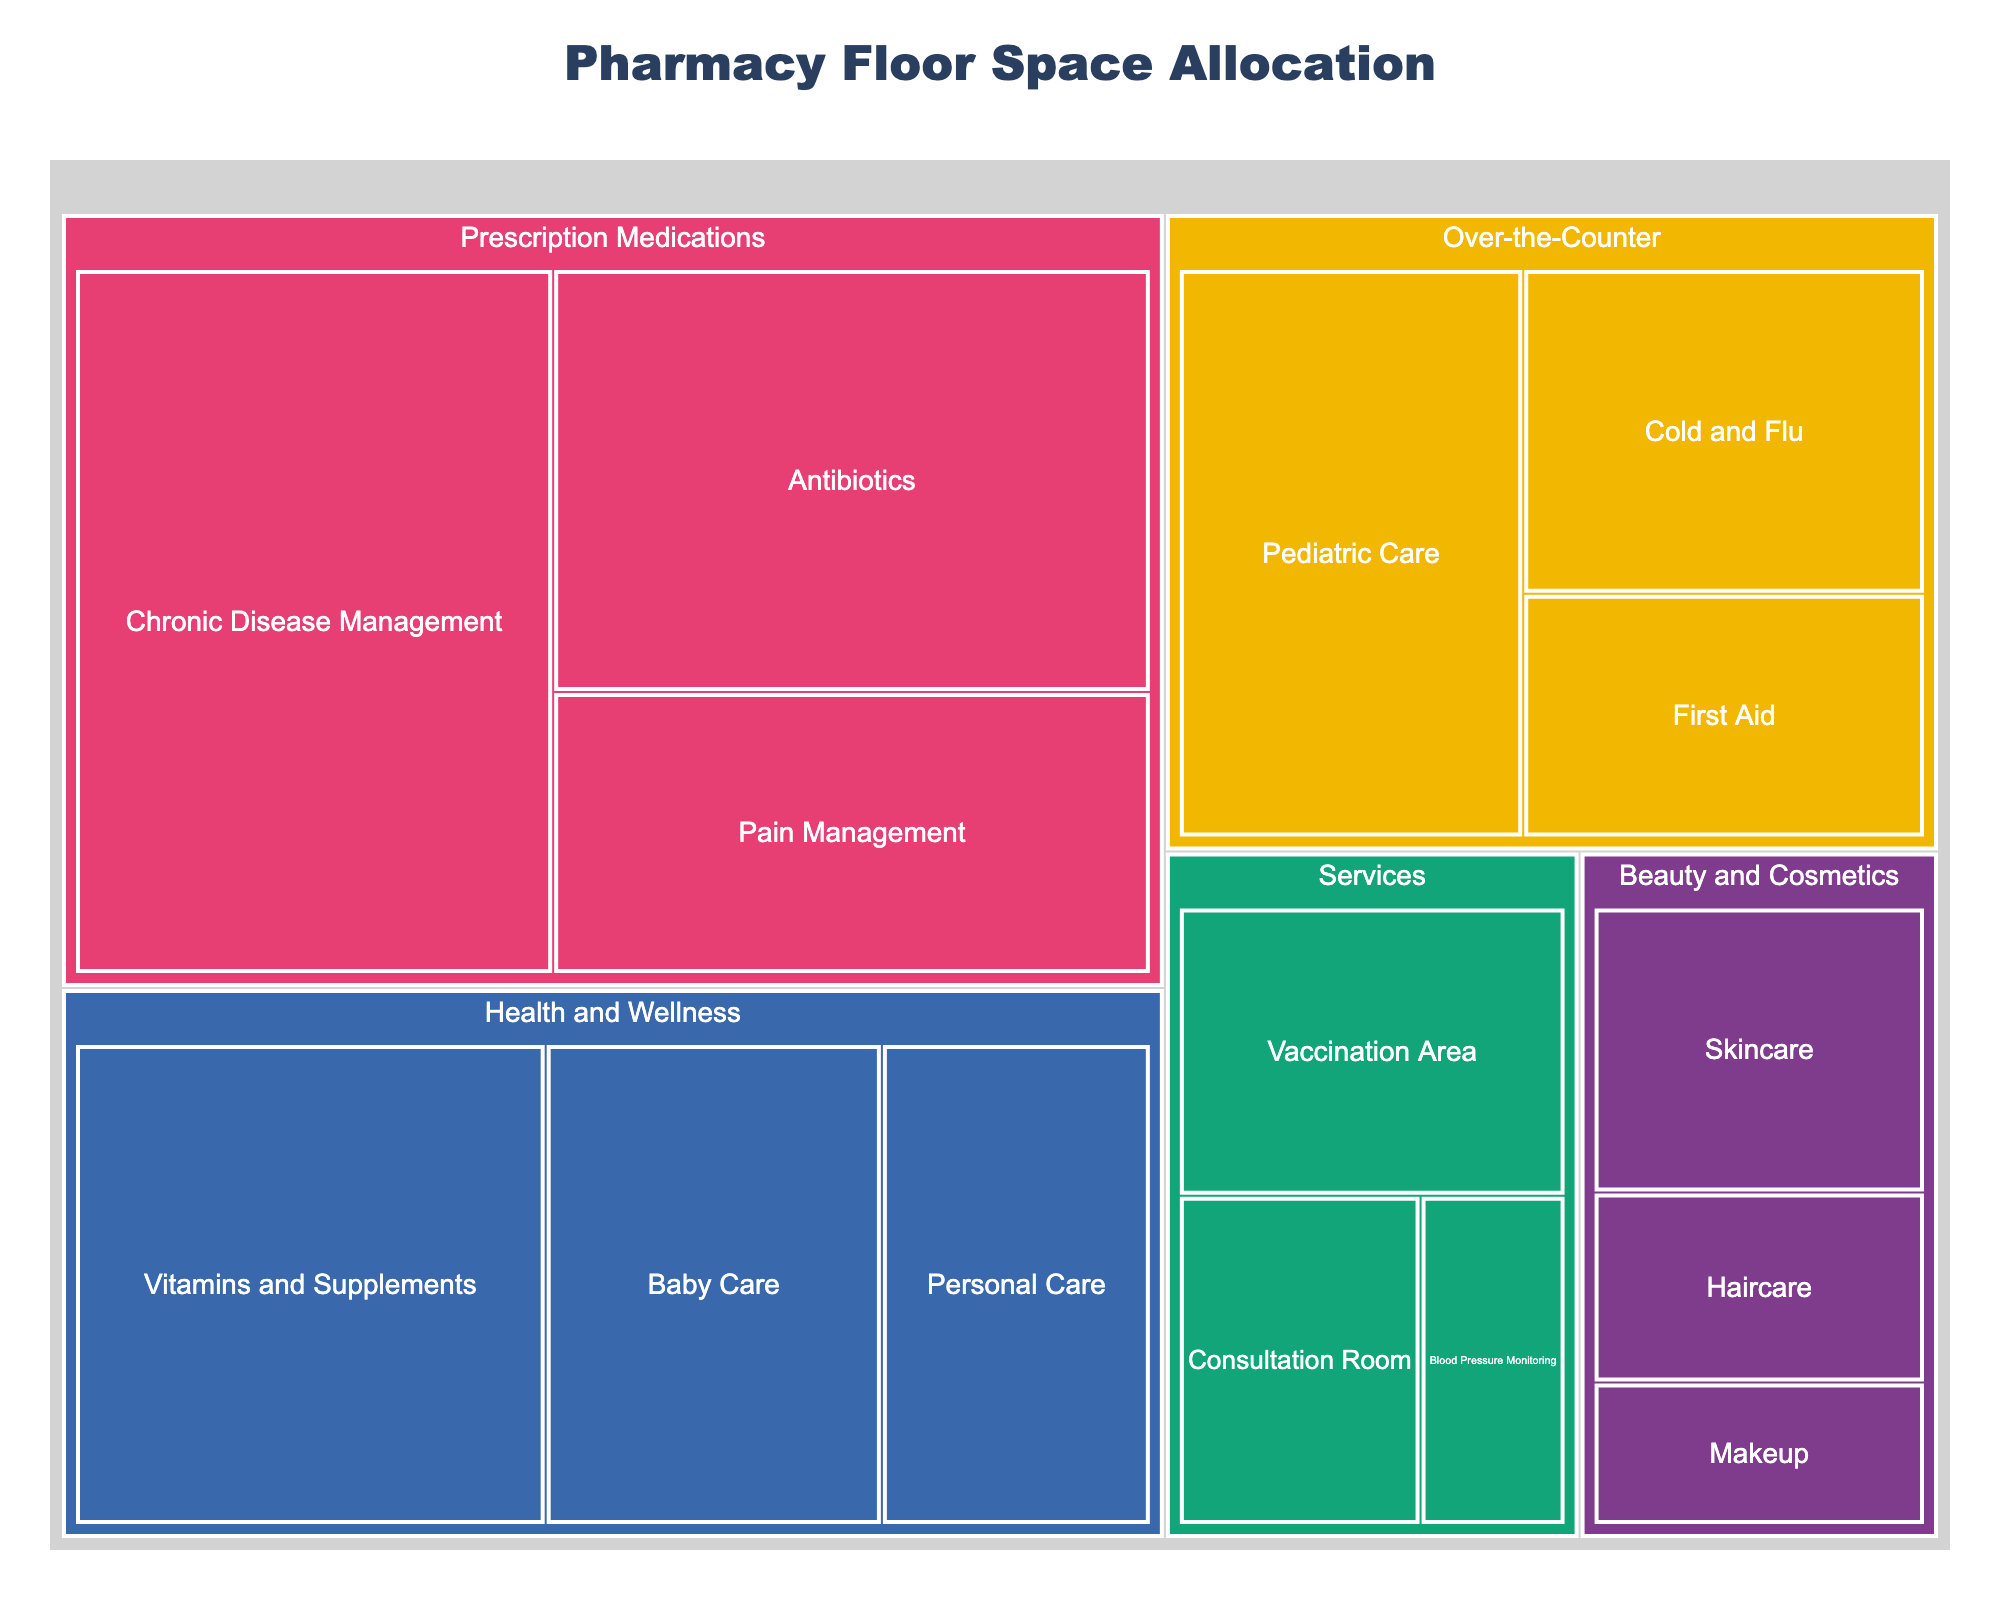What is the title of the figure? The title is usually located at the top center of the figure. By reading this, we understand the main subject of the visualization.
Answer: Pharmacy Floor Space Allocation Which category has the largest allocated floor space? By comparing the areas of the different categories, the largest allocated space will stand out visually.
Answer: Prescription Medications How much floor space is allocated to the 'First Aid' subcategory? Look for the 'First Aid' subcategory within the 'Over-the-Counter' category and note the area mentioned.
Answer: 6 sq ft What is the total floor space allocated to the 'Health and Wellness' category? Sum up the allocated areas for each subcategory under 'Health and Wellness.' These are 14 for Vitamins and Supplements, 10 for Baby Care, and 8 for Personal Care. Summing them up: 14 + 10 + 8 = 32.
Answer: 32 sq ft Which category occupies the smallest amount of floor space? Find the category with the smallest cumulative area of its subcategories. Visually, this will be the category with the smallest aggregate size in the treemap.
Answer: Beauty and Cosmetics Compare the floor space of 'Pediatric Care' and 'Pain Management.' Which one is larger, and by how much? Find the floor space for 'Pediatric Care' (12 sq ft) and 'Pain Management' (10 sq ft) and calculate the difference: 12 - 10 = 2. 'Pediatric Care' is larger by 2 sq ft.
Answer: Pediatric Care is larger by 2 sq ft What is the total floor space allocated to services offered at the pharmacy? Sum the areas for all subcategories under 'Services.' These are 7 for Vaccination Area, 5 for Consultation Room, and 3 for Blood Pressure Monitoring. Summing them up: 7 + 5 + 3 = 15.
Answer: 15 sq ft Among the subcategories in 'Over-the-Counter', which one has the highest allocated floor space? Compare the areas of subcategories within 'Over-the-Counter' and identify the maximum value. 'Pediatric Care' (12 sq ft) has the highest allocated floor space.
Answer: Pediatric Care Is the floor space for 'Antibiotics' larger or smaller than 'Skincare'? By how much? The floor space for 'Antibiotics' is 15 sq ft and for 'Skincare' is 6 sq ft. The difference is 15 - 6 = 9.
Answer: Larger by 9 sq ft What is the average floor space allocated per subcategory across all categories? Add all the areas from the subcategories: 15 + 20 + 10 + 8 + 12 + 6 + 14 + 10 + 8 + 7 + 5 + 3 + 6 + 4 + 3 = 131. There are 15 subcategories. The average floor space is 131 / 15 ≈ 8.73 sq ft.
Answer: Approximately 8.73 sq ft 